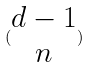<formula> <loc_0><loc_0><loc_500><loc_500>( \begin{matrix} d - 1 \\ n \end{matrix} )</formula> 